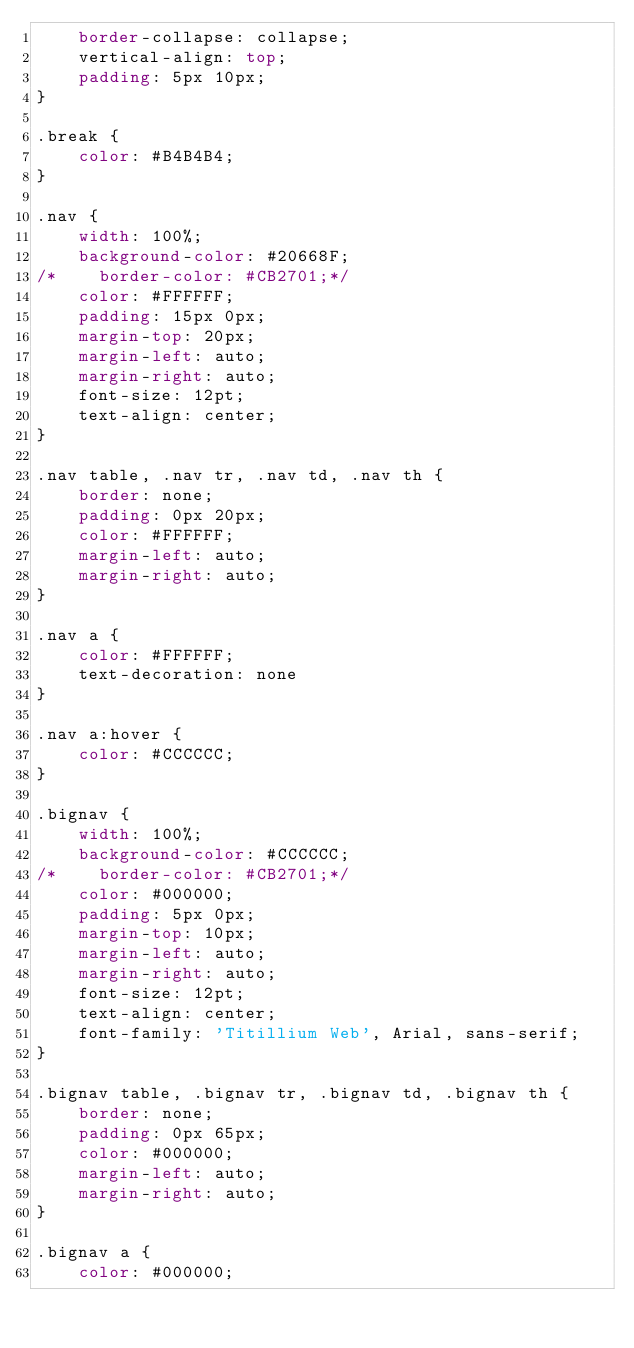Convert code to text. <code><loc_0><loc_0><loc_500><loc_500><_CSS_>    border-collapse: collapse;
    vertical-align: top;
    padding: 5px 10px;
}

.break {
    color: #B4B4B4;
}

.nav {
    width: 100%;
    background-color: #20668F;
/*    border-color: #CB2701;*/
    color: #FFFFFF;
    padding: 15px 0px;
    margin-top: 20px;
    margin-left: auto;
    margin-right: auto;
    font-size: 12pt;
    text-align: center;
}

.nav table, .nav tr, .nav td, .nav th {
    border: none;
    padding: 0px 20px;
    color: #FFFFFF;
    margin-left: auto;
    margin-right: auto;
}

.nav a {
    color: #FFFFFF;
    text-decoration: none
}

.nav a:hover {
    color: #CCCCCC;
}

.bignav {
    width: 100%;
    background-color: #CCCCCC;
/*    border-color: #CB2701;*/
    color: #000000;
    padding: 5px 0px;
    margin-top: 10px;
    margin-left: auto;
    margin-right: auto;
    font-size: 12pt;
    text-align: center;
    font-family: 'Titillium Web', Arial, sans-serif;
}

.bignav table, .bignav tr, .bignav td, .bignav th {
    border: none;
    padding: 0px 65px;
    color: #000000;
    margin-left: auto;
    margin-right: auto;
}

.bignav a {
    color: #000000;</code> 